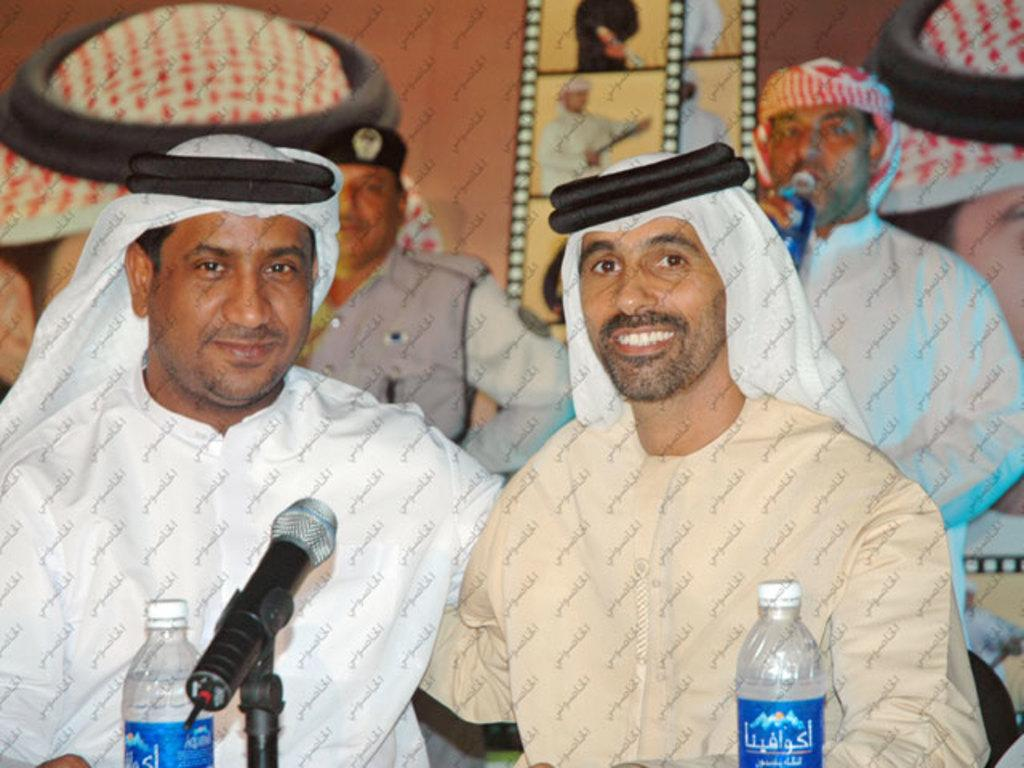How many people are in the image? There are two people in the image. What are the people doing in the image? The people are sitting on chairs. What is in front of the chairs? There is a table in front of the chairs. What is on the table? A mic is present on the table, along with two bottles. What can be seen in the background of the image? There is a poster visible in the background. How many books are on the table in the image? There are no books present on the table in the image. 